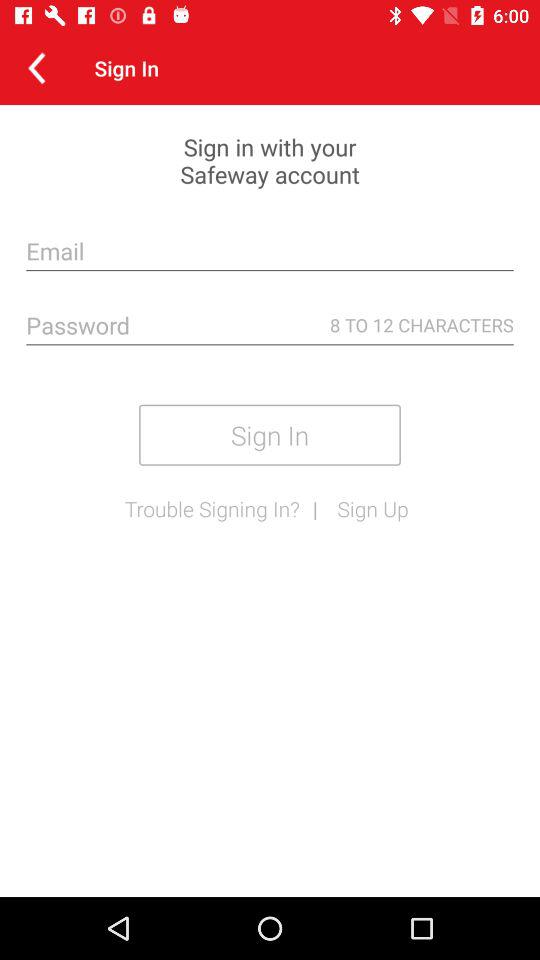How many text inputs are required to sign in?
Answer the question using a single word or phrase. 2 